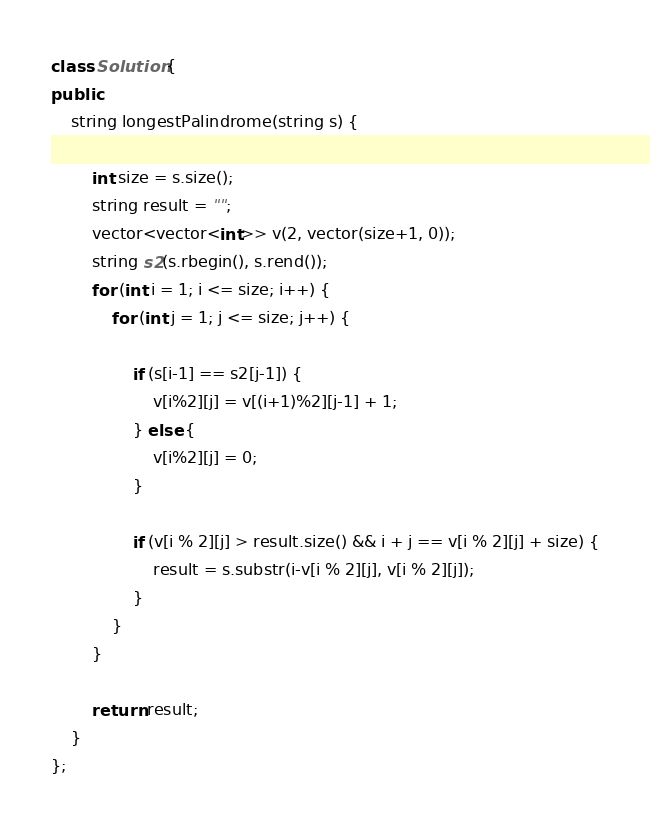Convert code to text. <code><loc_0><loc_0><loc_500><loc_500><_C++_>class Solution {
public:
    string longestPalindrome(string s) {

        int size = s.size();
        string result = "";
        vector<vector<int>> v(2, vector(size+1, 0));
        string s2(s.rbegin(), s.rend());
        for (int i = 1; i <= size; i++) {
            for (int j = 1; j <= size; j++) {

                if (s[i-1] == s2[j-1]) {
                    v[i%2][j] = v[(i+1)%2][j-1] + 1;
                } else {
                    v[i%2][j] = 0;
                }
                
                if (v[i % 2][j] > result.size() && i + j == v[i % 2][j] + size) {
                    result = s.substr(i-v[i % 2][j], v[i % 2][j]);
                }
            }
        }
        
        return result;
    }
};
</code> 